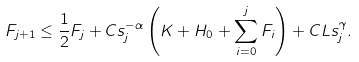Convert formula to latex. <formula><loc_0><loc_0><loc_500><loc_500>F _ { j + 1 } \leq \frac { 1 } { 2 } F _ { j } + C s ^ { - \alpha } _ { j } \left ( K + H _ { 0 } + \sum _ { i = 0 } ^ { j } F _ { i } \right ) + C L s _ { j } ^ { \gamma } .</formula> 